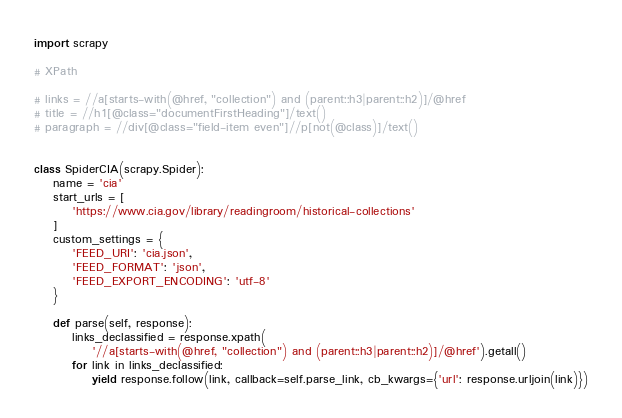Convert code to text. <code><loc_0><loc_0><loc_500><loc_500><_Python_>import scrapy

# XPath

# links = //a[starts-with(@href, "collection") and (parent::h3|parent::h2)]/@href
# title = //h1[@class="documentFirstHeading"]/text()
# paragraph = //div[@class="field-item even"]//p[not(@class)]/text()


class SpiderCIA(scrapy.Spider):
    name = 'cia'
    start_urls = [
        'https://www.cia.gov/library/readingroom/historical-collections'
    ]
    custom_settings = {
        'FEED_URI': 'cia.json',
        'FEED_FORMAT': 'json',
        'FEED_EXPORT_ENCODING': 'utf-8'
    }

    def parse(self, response):
        links_declassified = response.xpath(
            '//a[starts-with(@href, "collection") and (parent::h3|parent::h2)]/@href').getall()
        for link in links_declassified:
            yield response.follow(link, callback=self.parse_link, cb_kwargs={'url': response.urljoin(link)})
</code> 